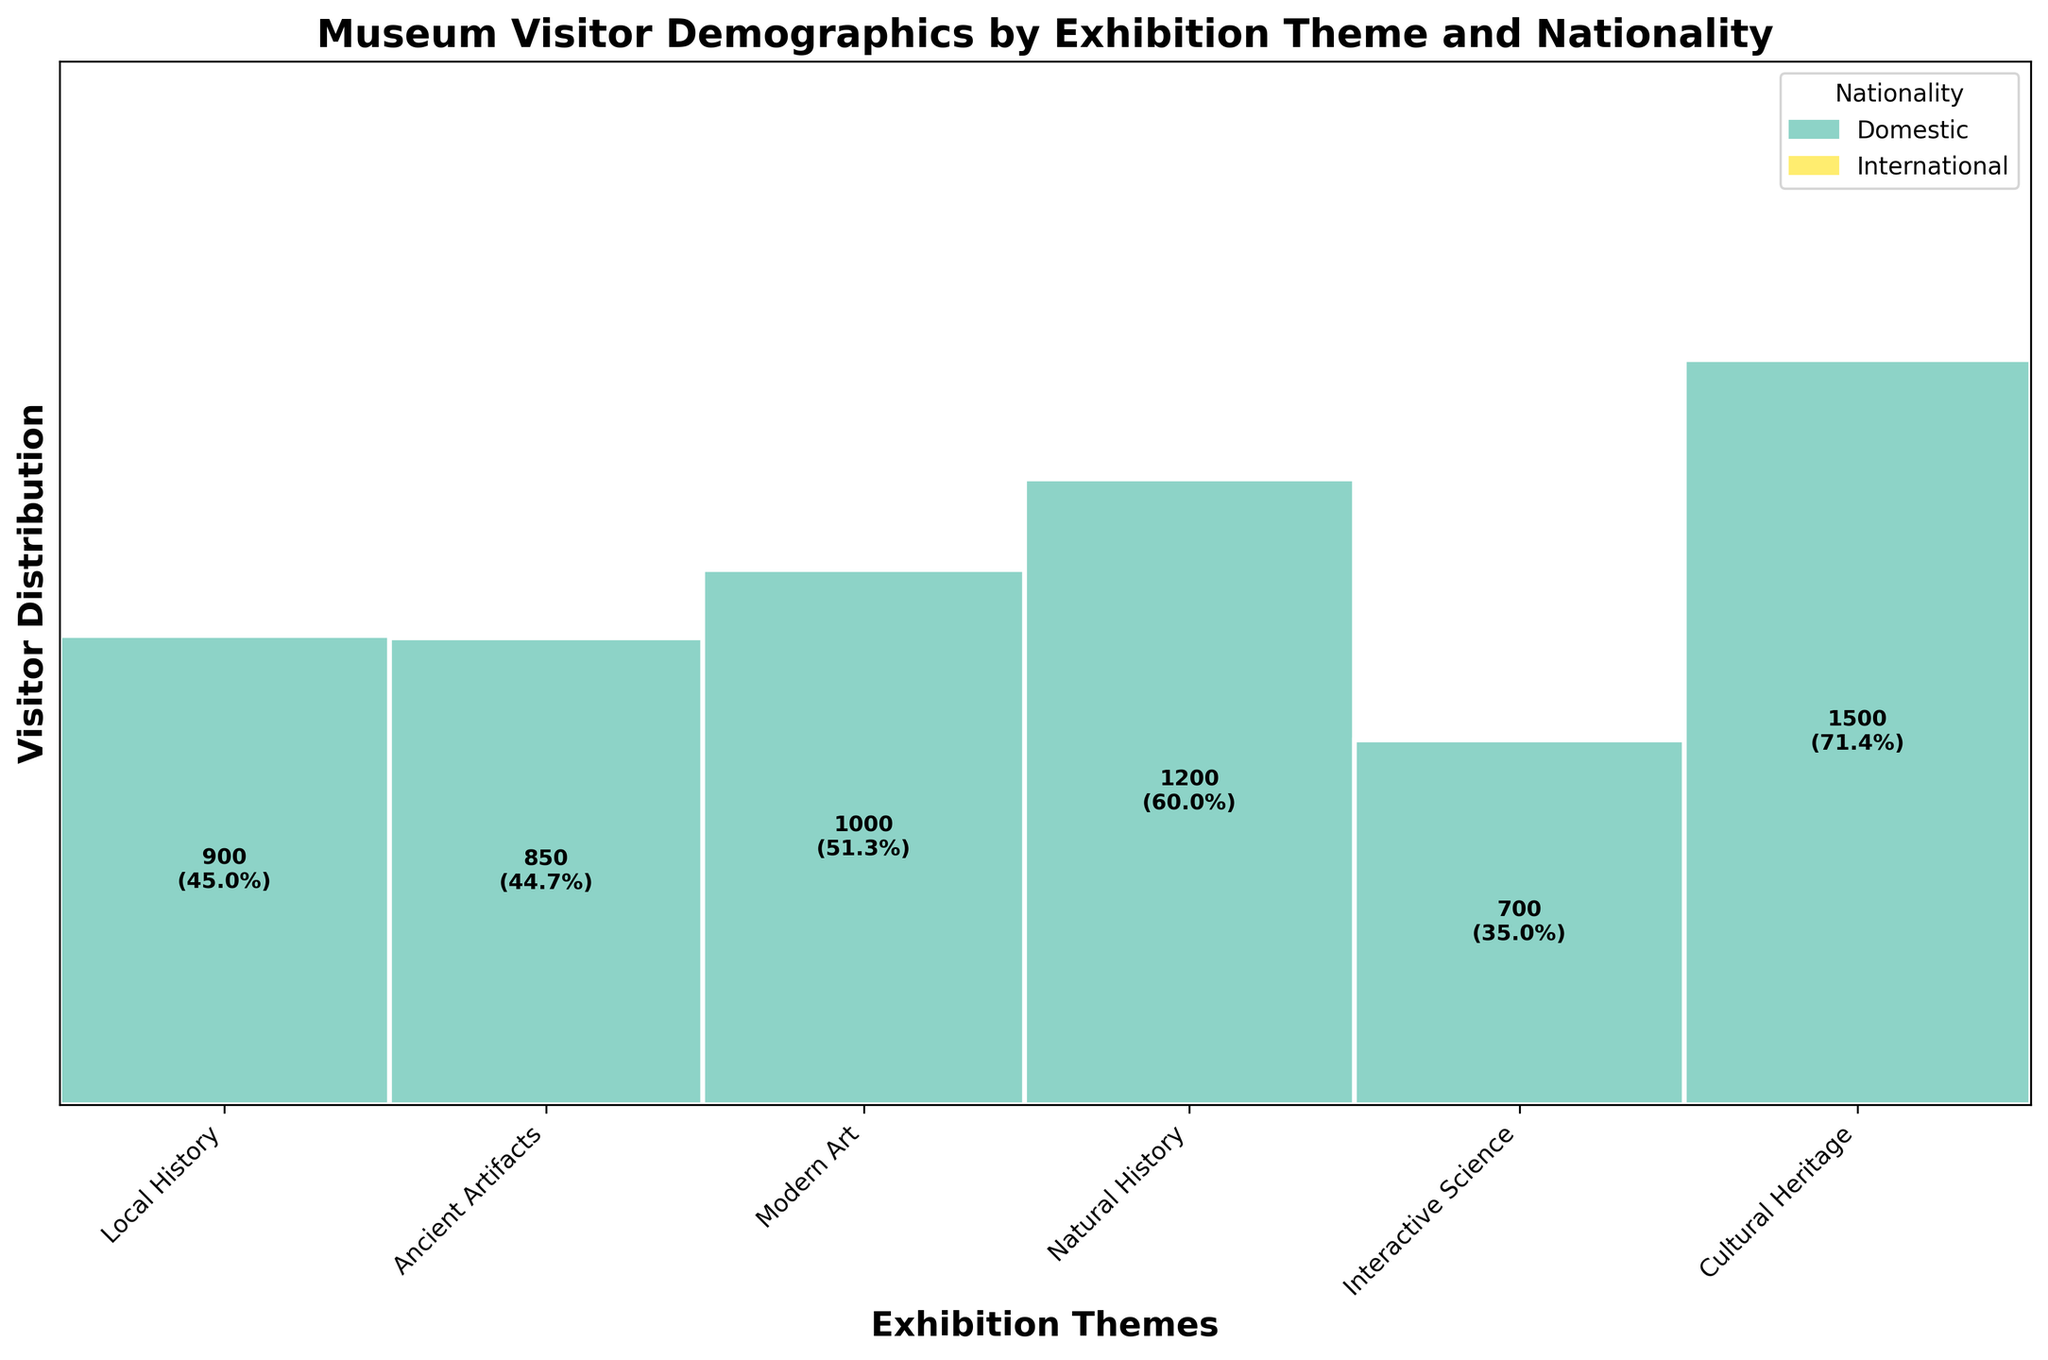What's the title of the plot? The title is located at the top of the plot, written in bold text.
Answer: Museum Visitor Demographics by Exhibition Theme and Nationality How many exhibition themes are displayed in the plot? The exhibition themes are represented by the ticks along the x-axis. Count the unique ticks.
Answer: 5 Which nationality visited the "Ancient Artifacts" exhibition more? Locate "Ancient Artifacts" on the x-axis, then compare the heights of the rectangles for "Domestic" and "International" visitors in that section.
Answer: International What percentage of visitors to the "Cultural Heritage" exhibition were international? Find "Cultural Heritage" on the x-axis, then look at the label inside the international section of the rectangle, which indicates the percentage.
Answer: 55.3% Which exhibition had the highest number of visitors from the domestic category? Look for the tallest rectangle under the "Domestic" color across all exhibitions.
Answer: Natural History Compare the total number of visitors to "Modern Art" with "Natural History". Which one had more visitors? Sum the heights of both the "Domestic" and "International" rectangles for each exhibition and compare the totals.
Answer: Natural History What is the difference in the number of international visitors between "Local History" and "Modern Art" exhibitions? Find the international visitor counts for both exhibitions and subtract the smaller from the larger.
Answer: 500 In which exhibition does the proportion of domestic to international visitors appear closest to equal? Check the rectangles' heights for domestic and international visitors across all exhibitions and find the pair with the most similar heights.
Answer: Interactive Science What is the smallest percentage of international visitors in any exhibition theme? Look at the percentage labels inside the rectangles for international visitors and identify the smallest value.
Answer: 28.6% In the "Natural History" exhibition, how does the proportion of domestic visitors compare to international visitors? Locate the "Natural History" section and compare the height of the "Domestic" rectangle relative to the "International" rectangle.
Answer: Much higher 